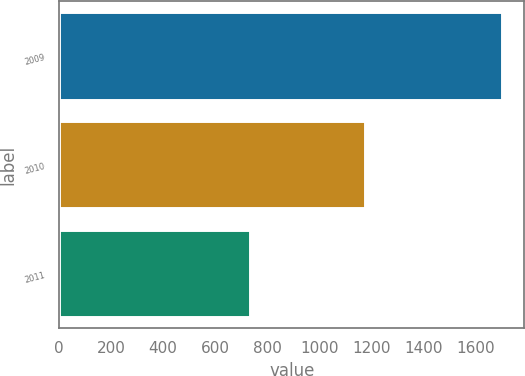Convert chart. <chart><loc_0><loc_0><loc_500><loc_500><bar_chart><fcel>2009<fcel>2010<fcel>2011<nl><fcel>1704<fcel>1178<fcel>735<nl></chart> 